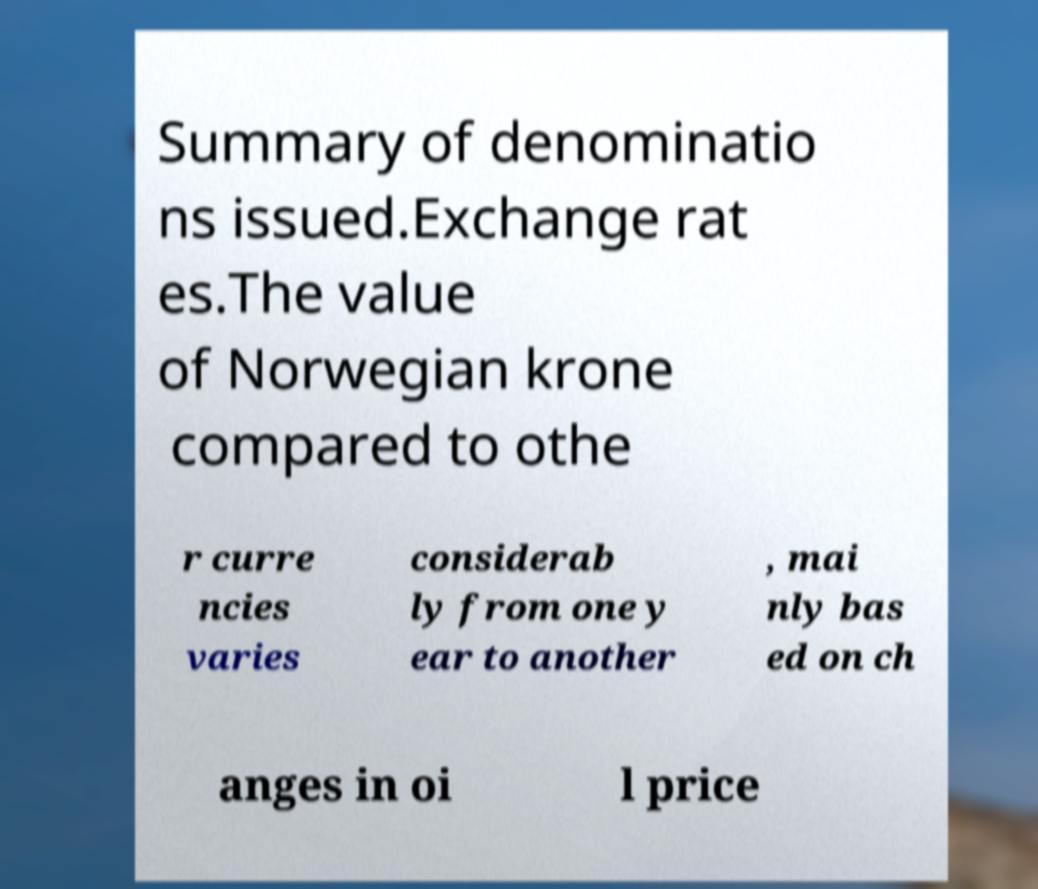I need the written content from this picture converted into text. Can you do that? Summary of denominatio ns issued.Exchange rat es.The value of Norwegian krone compared to othe r curre ncies varies considerab ly from one y ear to another , mai nly bas ed on ch anges in oi l price 